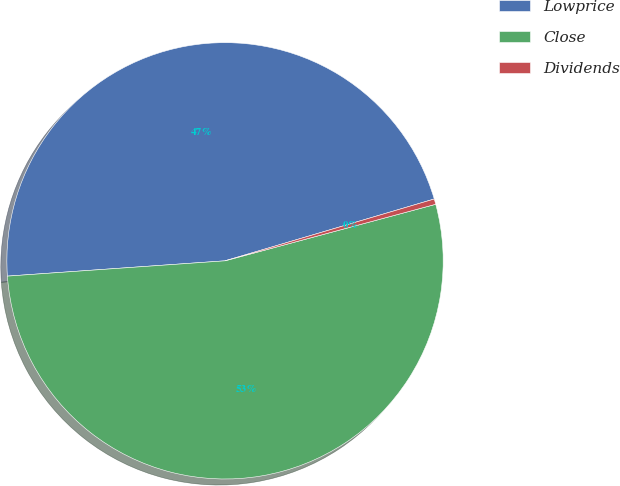<chart> <loc_0><loc_0><loc_500><loc_500><pie_chart><fcel>Lowprice<fcel>Close<fcel>Dividends<nl><fcel>46.55%<fcel>53.06%<fcel>0.4%<nl></chart> 